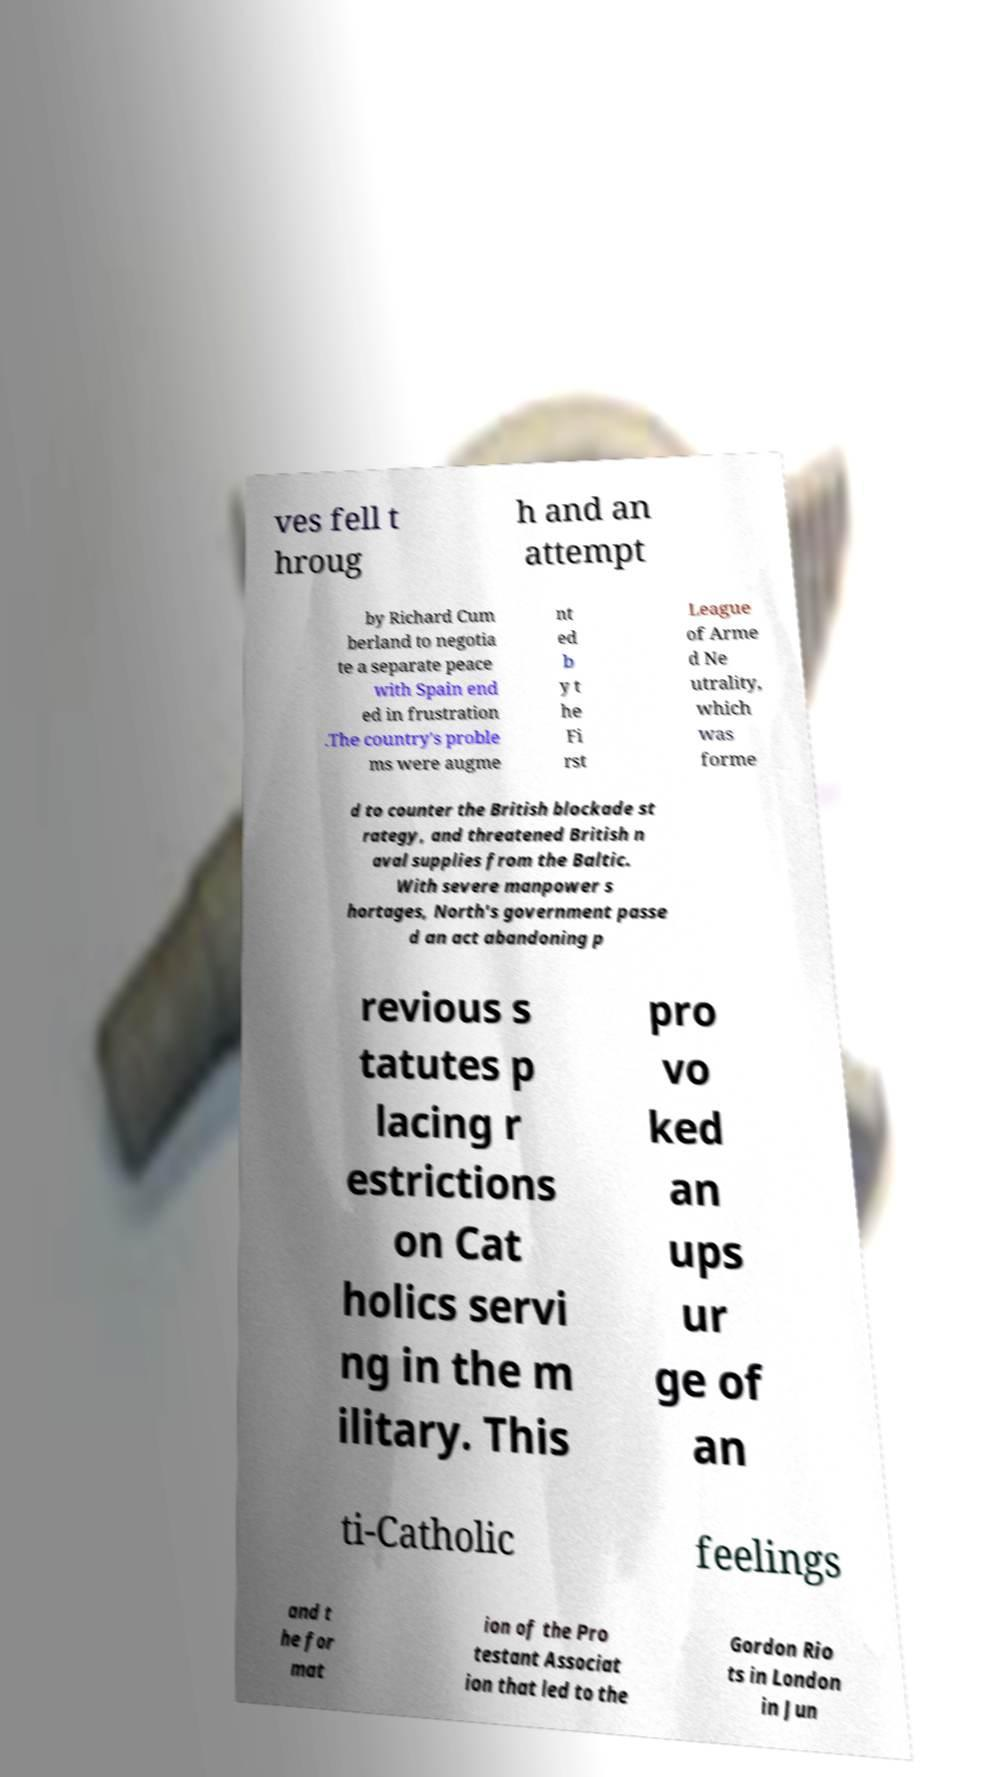Can you read and provide the text displayed in the image?This photo seems to have some interesting text. Can you extract and type it out for me? ves fell t hroug h and an attempt by Richard Cum berland to negotia te a separate peace with Spain end ed in frustration .The country's proble ms were augme nt ed b y t he Fi rst League of Arme d Ne utrality, which was forme d to counter the British blockade st rategy, and threatened British n aval supplies from the Baltic. With severe manpower s hortages, North's government passe d an act abandoning p revious s tatutes p lacing r estrictions on Cat holics servi ng in the m ilitary. This pro vo ked an ups ur ge of an ti-Catholic feelings and t he for mat ion of the Pro testant Associat ion that led to the Gordon Rio ts in London in Jun 